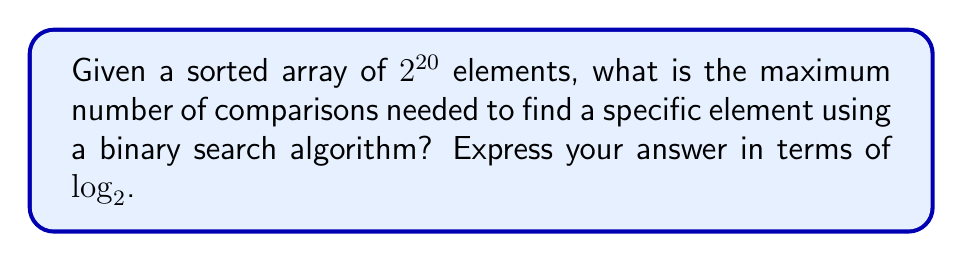Could you help me with this problem? Let's approach this step-by-step:

1) The binary search algorithm works by repeatedly dividing the search interval in half. At each step, it compares the middle element of the interval with the target value.

2) The efficiency of binary search is expressed in logarithmic time complexity, specifically $O(\log_2 n)$, where $n$ is the number of elements in the array.

3) In the worst-case scenario, the maximum number of comparisons is equal to $\log_2 n$, rounded up to the nearest integer.

4) In this case, we have $n = 2^{20}$ elements.

5) Let's calculate $\log_2(2^{20})$:

   $$\log_2(2^{20}) = 20$$

   This is because $\log_a(a^x) = x$ for any positive base $a$ and any real number $x$.

6) Since 20 is already an integer, we don't need to round up.

Therefore, the maximum number of comparisons needed is 20, which can be expressed as $\log_2(2^{20})$.

As an IT professional proficient in Python and PowerShell, you might appreciate that this logarithmic efficiency is what makes binary search so powerful for large datasets, especially when compared to linear search algorithms.
Answer: $\log_2(2^{20})$ 